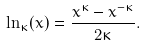Convert formula to latex. <formula><loc_0><loc_0><loc_500><loc_500>\ln _ { \kappa } ( x ) = \frac { x ^ { \kappa } - x ^ { - \kappa } } { 2 \kappa } .</formula> 